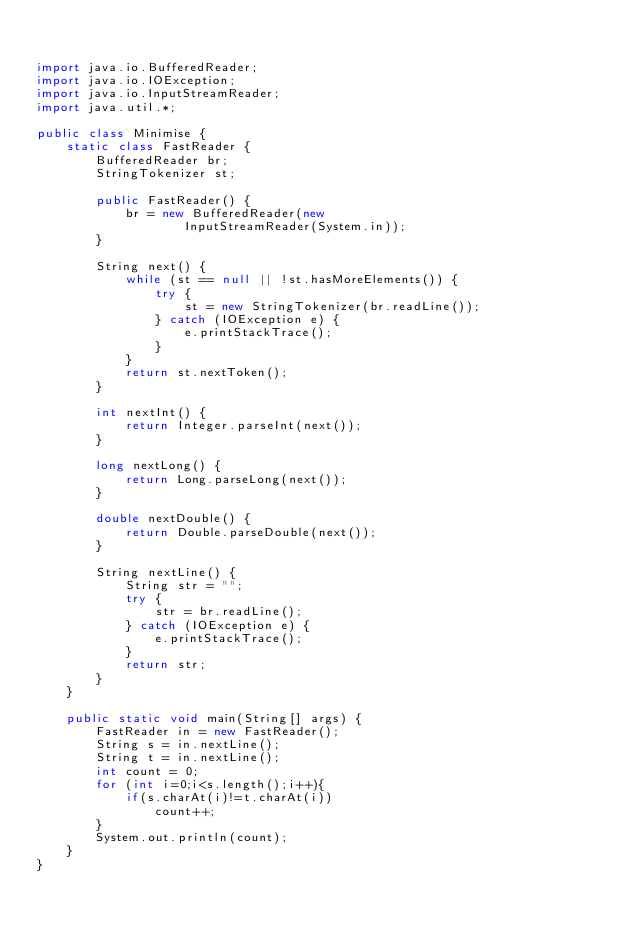Convert code to text. <code><loc_0><loc_0><loc_500><loc_500><_Java_>

import java.io.BufferedReader;
import java.io.IOException;
import java.io.InputStreamReader;
import java.util.*;

public class Minimise {
    static class FastReader {
        BufferedReader br;
        StringTokenizer st;

        public FastReader() {
            br = new BufferedReader(new
                    InputStreamReader(System.in));
        }

        String next() {
            while (st == null || !st.hasMoreElements()) {
                try {
                    st = new StringTokenizer(br.readLine());
                } catch (IOException e) {
                    e.printStackTrace();
                }
            }
            return st.nextToken();
        }

        int nextInt() {
            return Integer.parseInt(next());
        }

        long nextLong() {
            return Long.parseLong(next());
        }

        double nextDouble() {
            return Double.parseDouble(next());
        }

        String nextLine() {
            String str = "";
            try {
                str = br.readLine();
            } catch (IOException e) {
                e.printStackTrace();
            }
            return str;
        }
    }

    public static void main(String[] args) {
        FastReader in = new FastReader();
        String s = in.nextLine();
        String t = in.nextLine();
        int count = 0;
        for (int i=0;i<s.length();i++){
            if(s.charAt(i)!=t.charAt(i))
                count++;
        }
        System.out.println(count);
    }
}</code> 